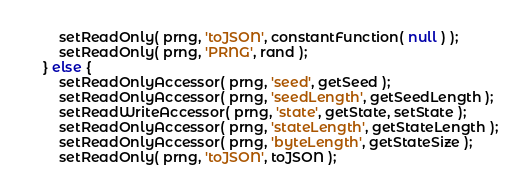<code> <loc_0><loc_0><loc_500><loc_500><_JavaScript_>		setReadOnly( prng, 'toJSON', constantFunction( null ) );
		setReadOnly( prng, 'PRNG', rand );
	} else {
		setReadOnlyAccessor( prng, 'seed', getSeed );
		setReadOnlyAccessor( prng, 'seedLength', getSeedLength );
		setReadWriteAccessor( prng, 'state', getState, setState );
		setReadOnlyAccessor( prng, 'stateLength', getStateLength );
		setReadOnlyAccessor( prng, 'byteLength', getStateSize );
		setReadOnly( prng, 'toJSON', toJSON );</code> 